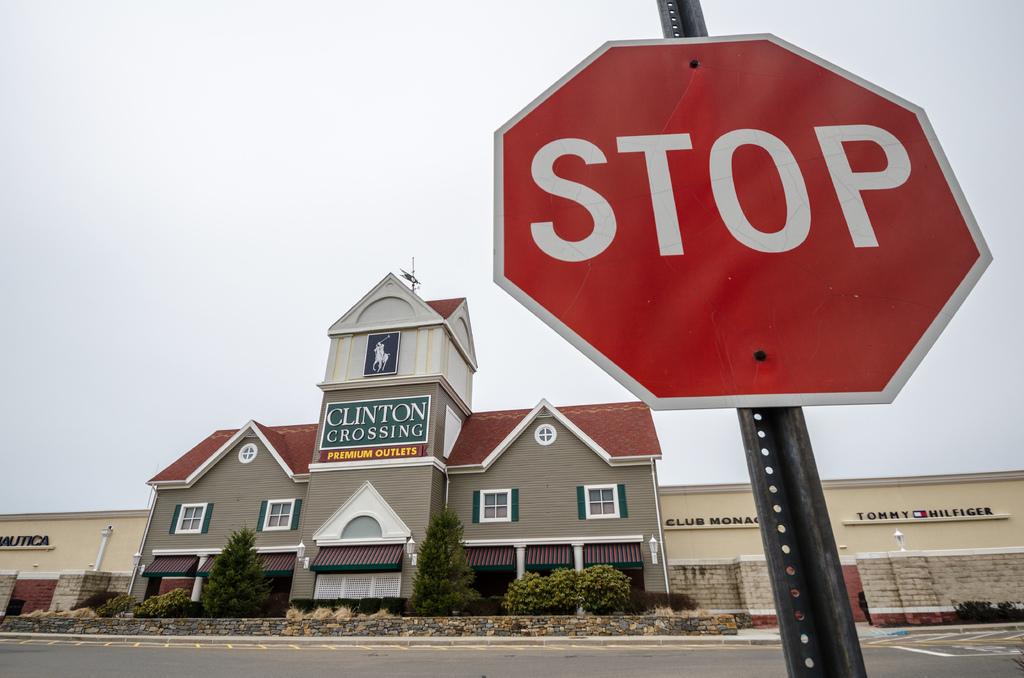What clothing brand is mentioned on the tan store behind the stop sign?
Your answer should be very brief. Clinton crossing. What is the name of the outlets?
Provide a short and direct response. Clinton crossing. 